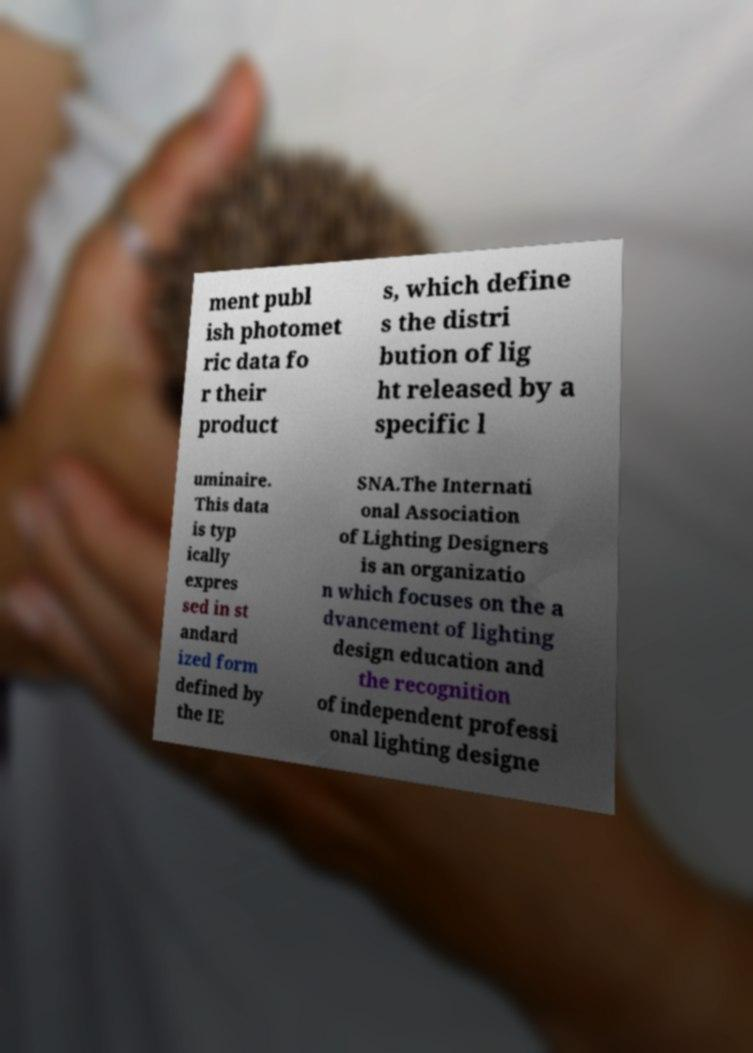What messages or text are displayed in this image? I need them in a readable, typed format. ment publ ish photomet ric data fo r their product s, which define s the distri bution of lig ht released by a specific l uminaire. This data is typ ically expres sed in st andard ized form defined by the IE SNA.The Internati onal Association of Lighting Designers is an organizatio n which focuses on the a dvancement of lighting design education and the recognition of independent professi onal lighting designe 